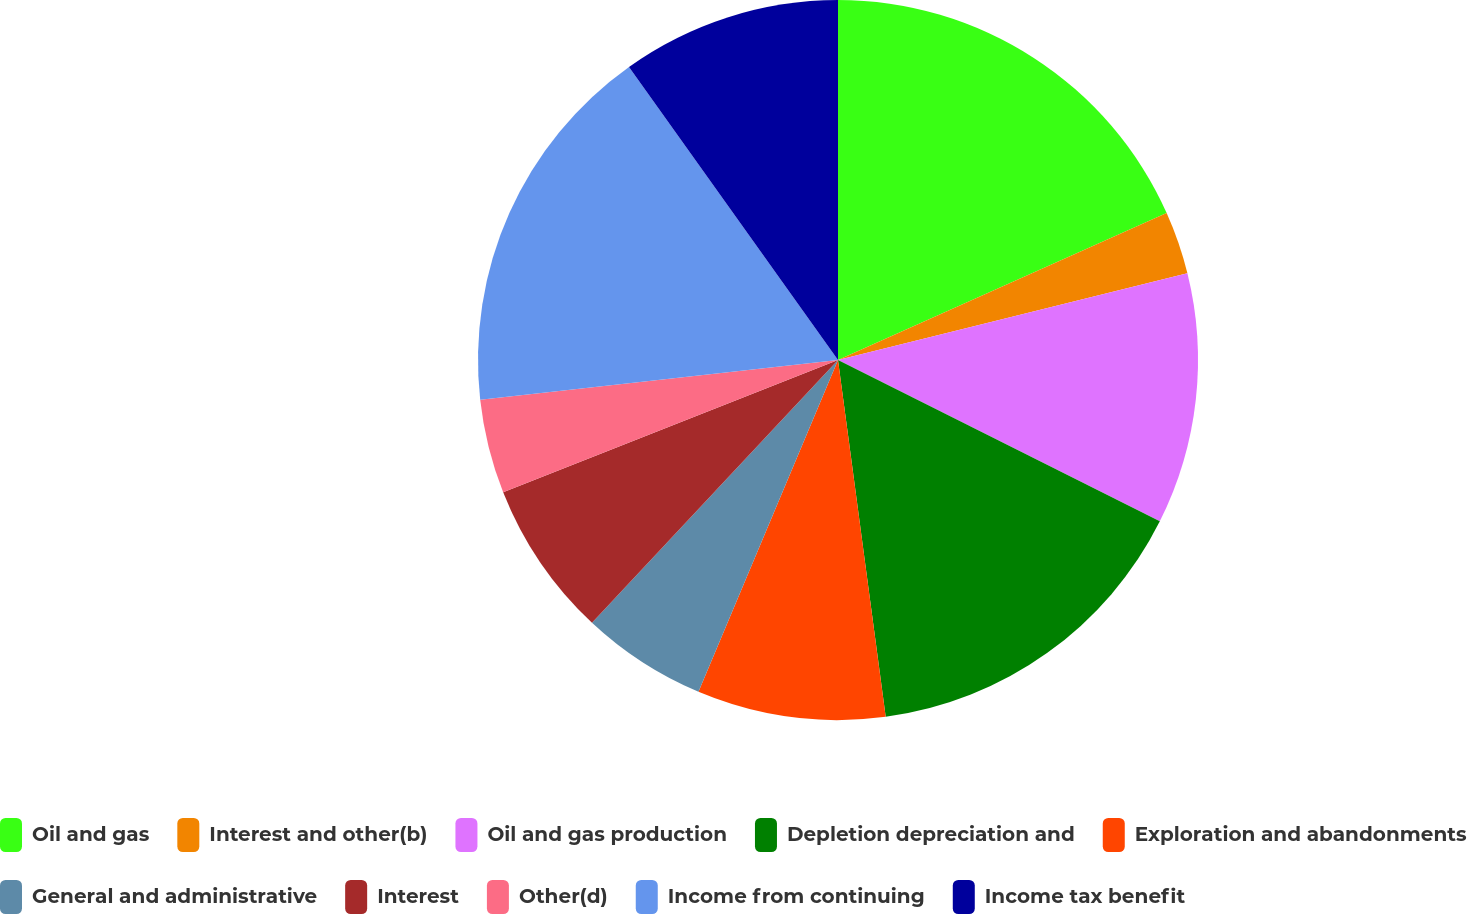Convert chart to OTSL. <chart><loc_0><loc_0><loc_500><loc_500><pie_chart><fcel>Oil and gas<fcel>Interest and other(b)<fcel>Oil and gas production<fcel>Depletion depreciation and<fcel>Exploration and abandonments<fcel>General and administrative<fcel>Interest<fcel>Other(d)<fcel>Income from continuing<fcel>Income tax benefit<nl><fcel>18.31%<fcel>2.82%<fcel>11.27%<fcel>15.49%<fcel>8.45%<fcel>5.64%<fcel>7.04%<fcel>4.23%<fcel>16.9%<fcel>9.86%<nl></chart> 